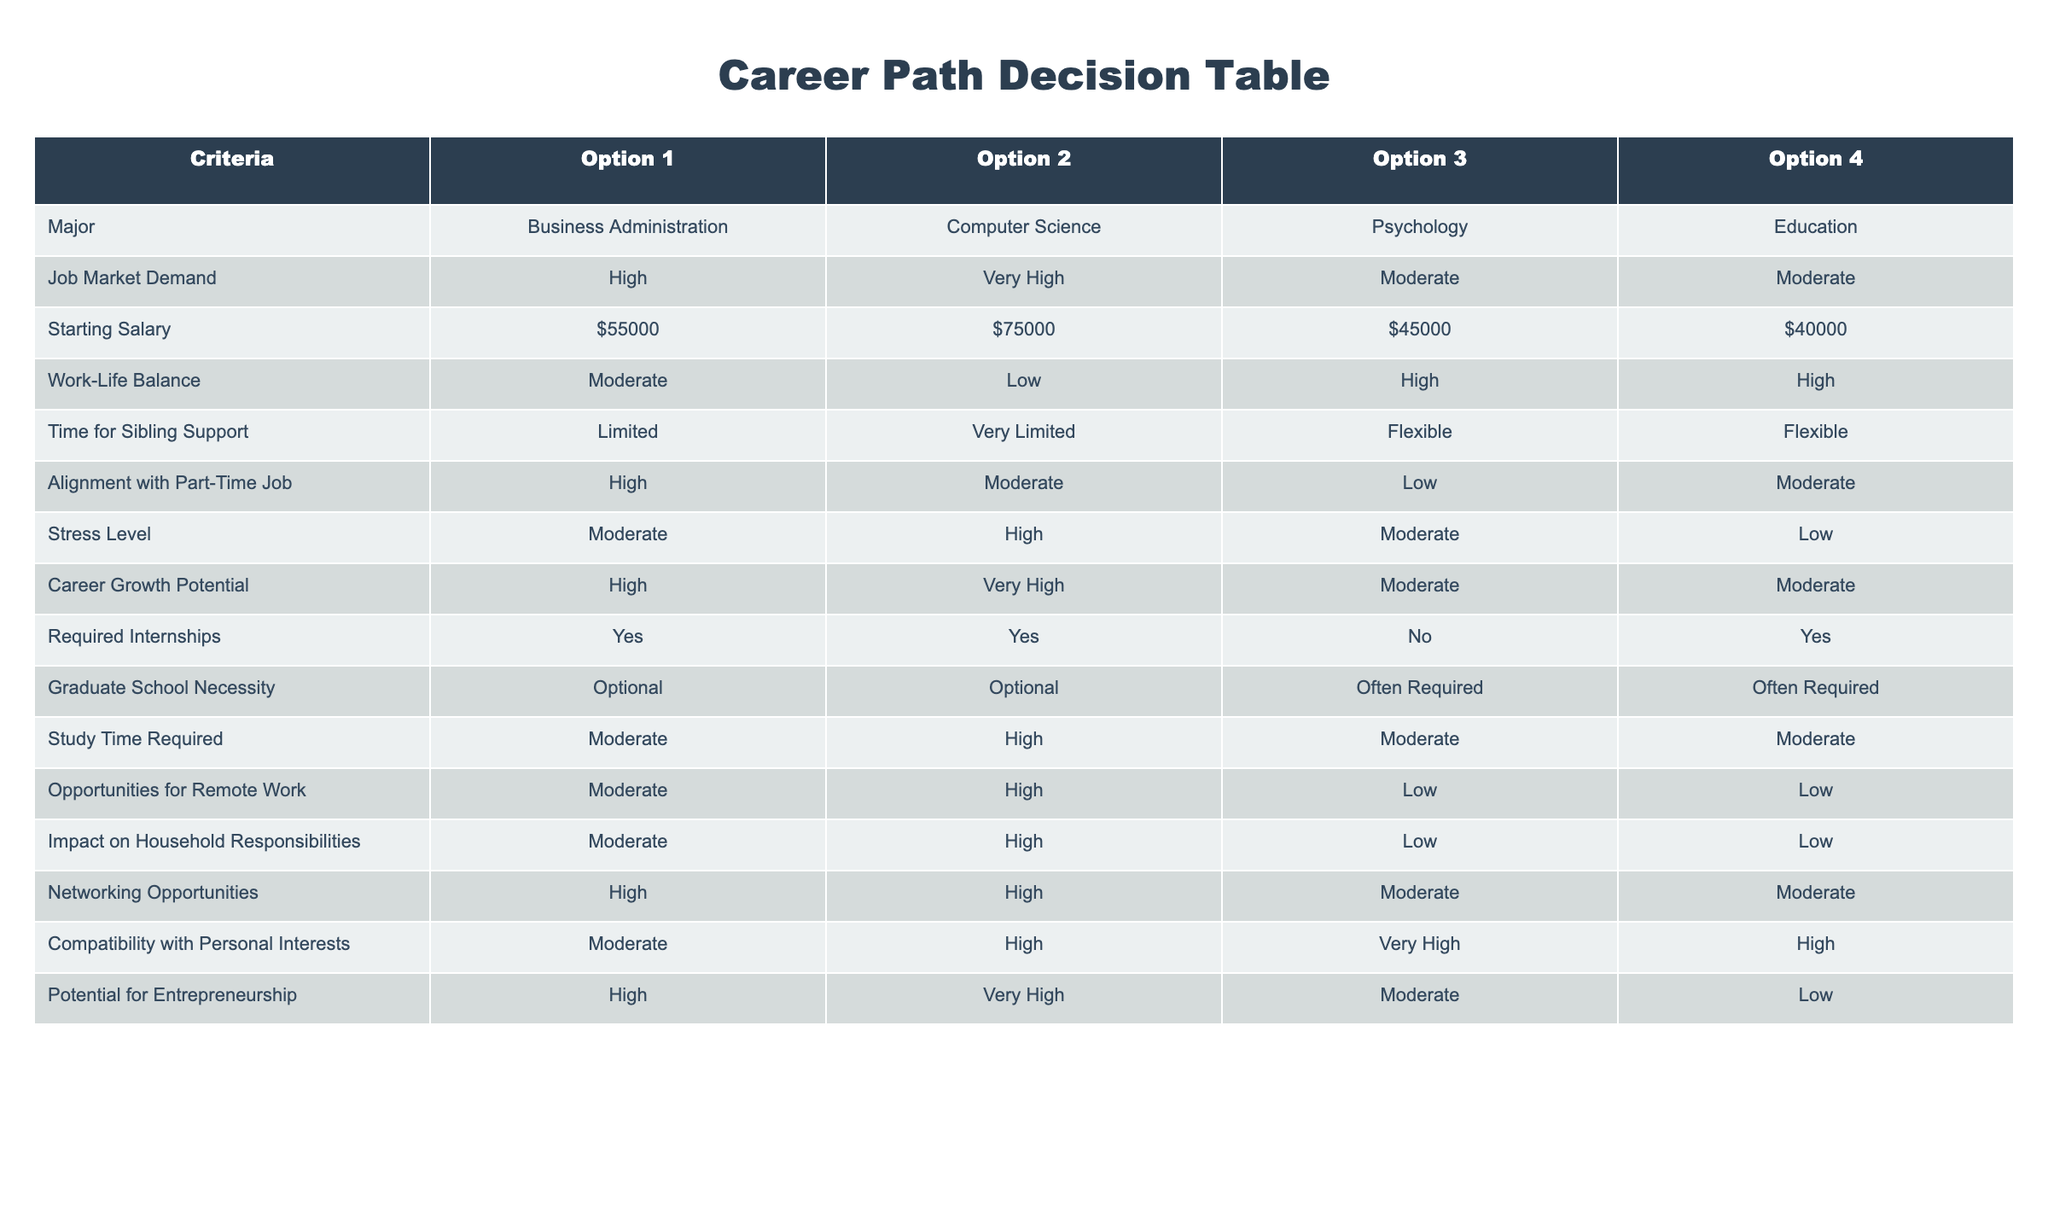What is the starting salary for a Computer Science major? According to the table, the starting salary for a Computer Science major is listed as $75,000.
Answer: $75,000 How many options have high job market demand? The options listed are Business Administration, Computer Science, Psychology, and Education. High demand is noted for Business Administration and Computer Science. Therefore, there are 2 options with high job market demand.
Answer: 2 Which major has the lowest stress level? Looking at the stress level column, Education is noted as having a low stress level compared to the other options.
Answer: Education Is a graduate school degree often required for Psychology majors? Yes, the table indicates that Psychology as a major often requires a graduate school degree.
Answer: Yes What is the average starting salary for options that have high work-life balance? The two options with high work-life balance are Psychology and Education. Their starting salaries are $45,000 and $40,000 respectively. The average is calculated as (45,000 + 40,000) / 2 = 42,500.
Answer: $42,500 What is the stress level difference between Computer Science and Education? From the table, Computer Science has a high stress level, while Education has a low stress level. The difference is thus high (Computer Science) minus low (Education).
Answer: High Which major offers the most flexibility for sibling support? The table shows that both Psychology and Education have flexible time for sibling support, while Business Administration and Computer Science are listed as limited and very limited, respectively.
Answer: Psychology and Education How many options listed provide moderate networking opportunities? The options Business Administration and Computer Science provide high networking opportunities while Psychology and Education are noted for moderate networking opportunities. Thus, there are 2 options with moderate networking opportunities.
Answer: 2 What is the potential for entrepreneurship in the Business Administration major? The table indicates that the potential for entrepreneurship in Business Administration is high.
Answer: High 